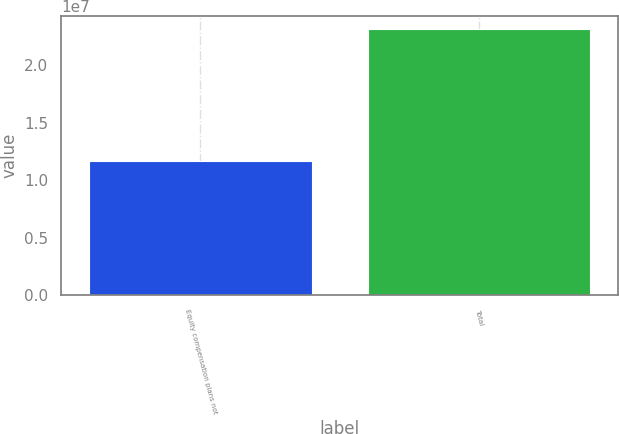Convert chart to OTSL. <chart><loc_0><loc_0><loc_500><loc_500><bar_chart><fcel>Equity compensation plans not<fcel>Total<nl><fcel>1.17021e+07<fcel>2.31266e+07<nl></chart> 